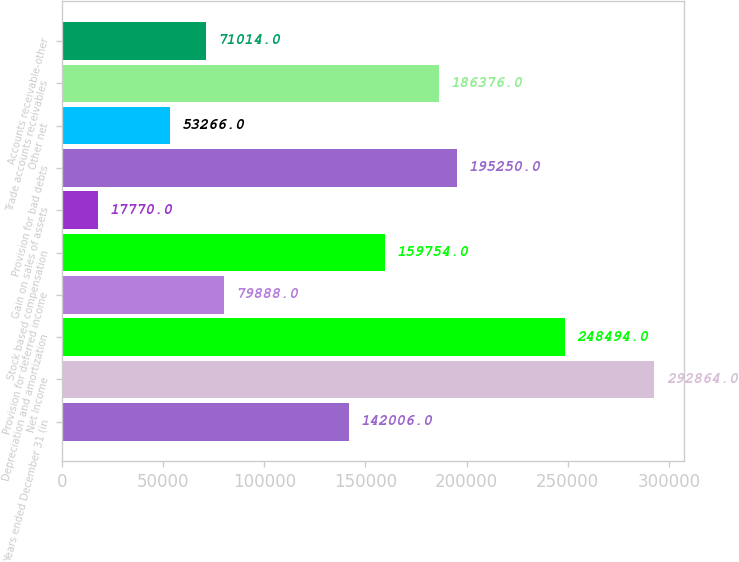Convert chart to OTSL. <chart><loc_0><loc_0><loc_500><loc_500><bar_chart><fcel>Years ended December 31 (in<fcel>Net Income<fcel>Depreciation and amortization<fcel>Provision for deferred income<fcel>Stock based compensation<fcel>Gain on sales of assets<fcel>Provision for bad debts<fcel>Other net<fcel>Trade accounts receivables<fcel>Accounts receivable-other<nl><fcel>142006<fcel>292864<fcel>248494<fcel>79888<fcel>159754<fcel>17770<fcel>195250<fcel>53266<fcel>186376<fcel>71014<nl></chart> 